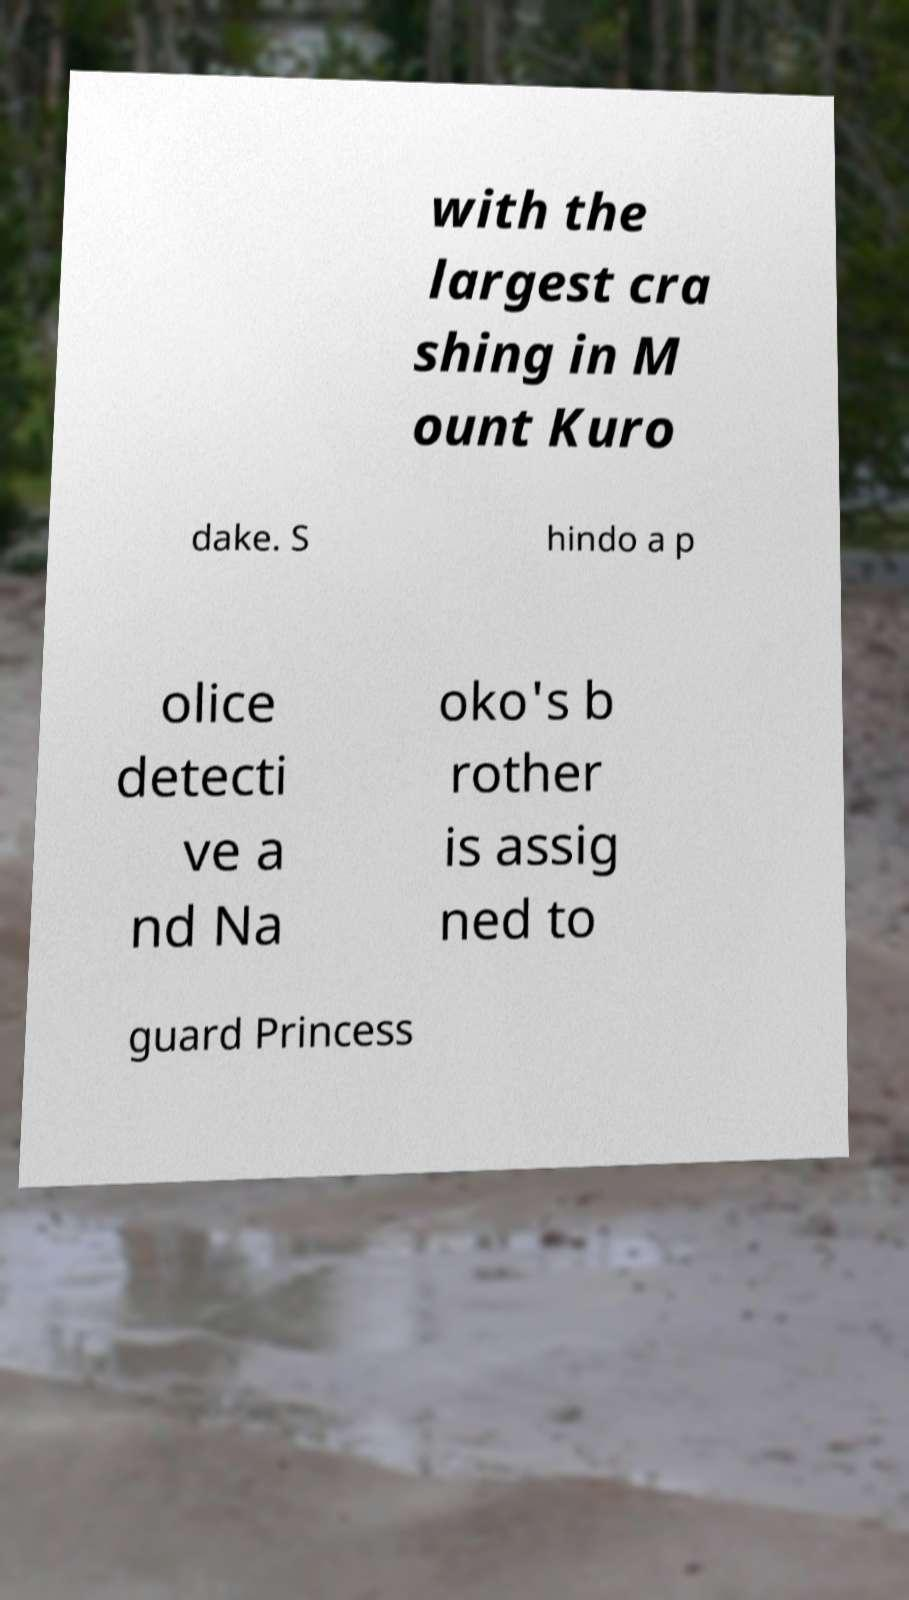I need the written content from this picture converted into text. Can you do that? with the largest cra shing in M ount Kuro dake. S hindo a p olice detecti ve a nd Na oko's b rother is assig ned to guard Princess 